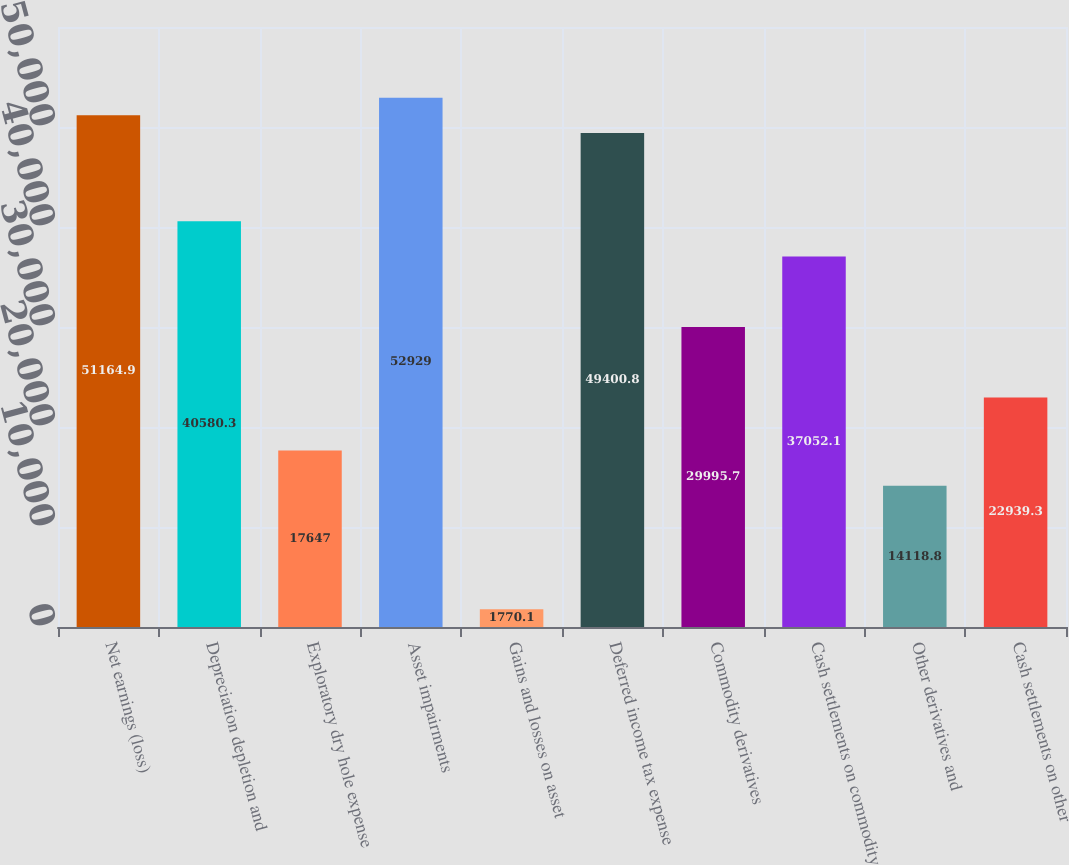Convert chart. <chart><loc_0><loc_0><loc_500><loc_500><bar_chart><fcel>Net earnings (loss)<fcel>Depreciation depletion and<fcel>Exploratory dry hole expense<fcel>Asset impairments<fcel>Gains and losses on asset<fcel>Deferred income tax expense<fcel>Commodity derivatives<fcel>Cash settlements on commodity<fcel>Other derivatives and<fcel>Cash settlements on other<nl><fcel>51164.9<fcel>40580.3<fcel>17647<fcel>52929<fcel>1770.1<fcel>49400.8<fcel>29995.7<fcel>37052.1<fcel>14118.8<fcel>22939.3<nl></chart> 